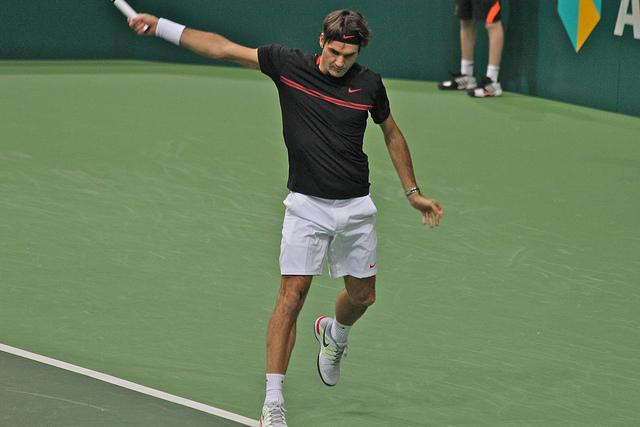What is the man in the foreground wearing on his feet? Please explain your reasoning. sneakers. The athlete in this picture wears shoes suitable for athletics. 